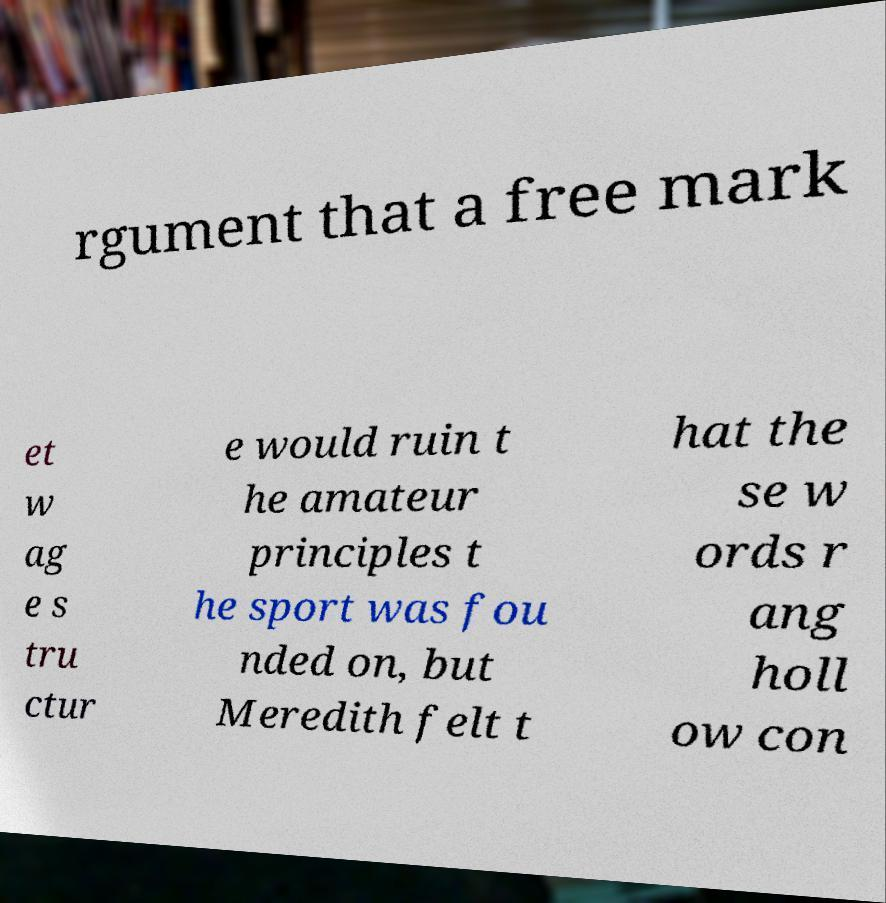For documentation purposes, I need the text within this image transcribed. Could you provide that? rgument that a free mark et w ag e s tru ctur e would ruin t he amateur principles t he sport was fou nded on, but Meredith felt t hat the se w ords r ang holl ow con 